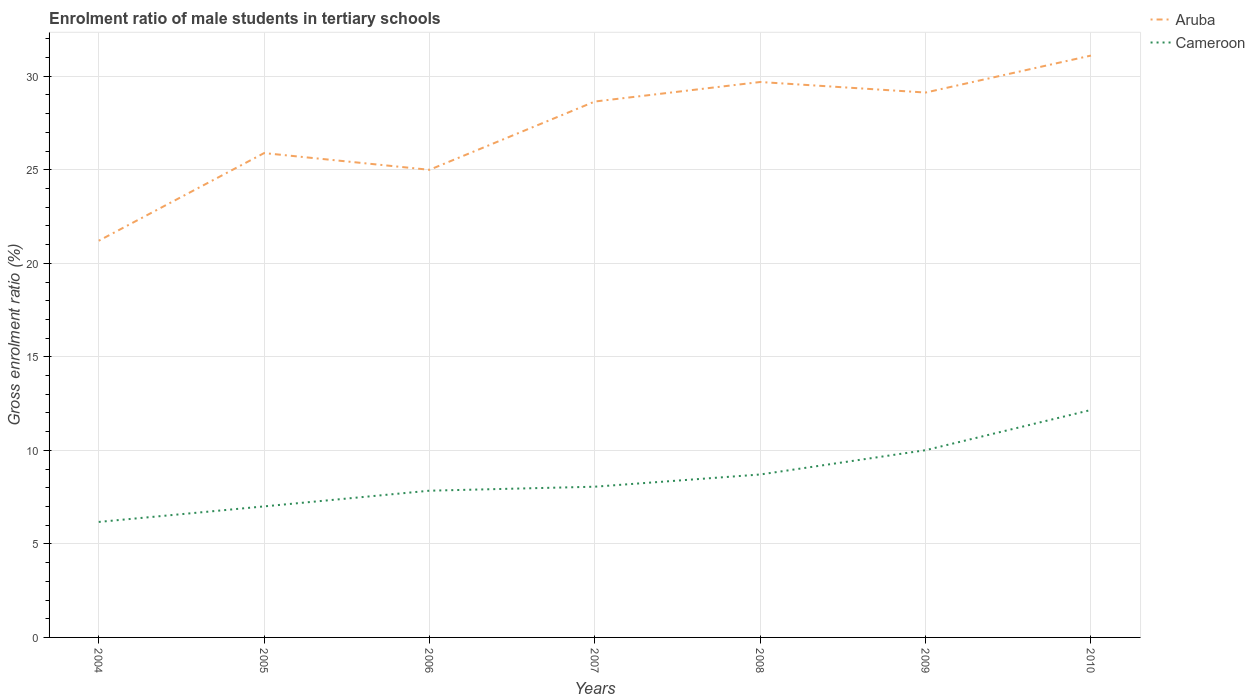Does the line corresponding to Cameroon intersect with the line corresponding to Aruba?
Your response must be concise. No. Is the number of lines equal to the number of legend labels?
Give a very brief answer. Yes. Across all years, what is the maximum enrolment ratio of male students in tertiary schools in Cameroon?
Keep it short and to the point. 6.17. What is the total enrolment ratio of male students in tertiary schools in Aruba in the graph?
Your answer should be compact. -3.24. What is the difference between the highest and the second highest enrolment ratio of male students in tertiary schools in Cameroon?
Your answer should be very brief. 5.99. What is the difference between the highest and the lowest enrolment ratio of male students in tertiary schools in Cameroon?
Keep it short and to the point. 3. Is the enrolment ratio of male students in tertiary schools in Cameroon strictly greater than the enrolment ratio of male students in tertiary schools in Aruba over the years?
Offer a terse response. Yes. How many lines are there?
Give a very brief answer. 2. How many years are there in the graph?
Give a very brief answer. 7. Are the values on the major ticks of Y-axis written in scientific E-notation?
Your answer should be compact. No. Does the graph contain any zero values?
Make the answer very short. No. Does the graph contain grids?
Offer a very short reply. Yes. Where does the legend appear in the graph?
Provide a succinct answer. Top right. What is the title of the graph?
Your answer should be compact. Enrolment ratio of male students in tertiary schools. Does "Saudi Arabia" appear as one of the legend labels in the graph?
Keep it short and to the point. No. What is the label or title of the Y-axis?
Offer a terse response. Gross enrolment ratio (%). What is the Gross enrolment ratio (%) in Aruba in 2004?
Provide a short and direct response. 21.21. What is the Gross enrolment ratio (%) of Cameroon in 2004?
Offer a terse response. 6.17. What is the Gross enrolment ratio (%) in Aruba in 2005?
Your answer should be compact. 25.89. What is the Gross enrolment ratio (%) in Cameroon in 2005?
Provide a short and direct response. 7.01. What is the Gross enrolment ratio (%) in Aruba in 2006?
Your response must be concise. 25. What is the Gross enrolment ratio (%) in Cameroon in 2006?
Offer a terse response. 7.84. What is the Gross enrolment ratio (%) of Aruba in 2007?
Offer a very short reply. 28.65. What is the Gross enrolment ratio (%) in Cameroon in 2007?
Your response must be concise. 8.06. What is the Gross enrolment ratio (%) in Aruba in 2008?
Provide a succinct answer. 29.69. What is the Gross enrolment ratio (%) in Cameroon in 2008?
Provide a succinct answer. 8.71. What is the Gross enrolment ratio (%) in Aruba in 2009?
Make the answer very short. 29.13. What is the Gross enrolment ratio (%) in Cameroon in 2009?
Make the answer very short. 10.01. What is the Gross enrolment ratio (%) of Aruba in 2010?
Offer a terse response. 31.11. What is the Gross enrolment ratio (%) of Cameroon in 2010?
Ensure brevity in your answer.  12.16. Across all years, what is the maximum Gross enrolment ratio (%) of Aruba?
Your answer should be very brief. 31.11. Across all years, what is the maximum Gross enrolment ratio (%) in Cameroon?
Offer a very short reply. 12.16. Across all years, what is the minimum Gross enrolment ratio (%) in Aruba?
Keep it short and to the point. 21.21. Across all years, what is the minimum Gross enrolment ratio (%) of Cameroon?
Offer a very short reply. 6.17. What is the total Gross enrolment ratio (%) in Aruba in the graph?
Provide a short and direct response. 190.68. What is the total Gross enrolment ratio (%) in Cameroon in the graph?
Offer a terse response. 59.96. What is the difference between the Gross enrolment ratio (%) in Aruba in 2004 and that in 2005?
Your response must be concise. -4.69. What is the difference between the Gross enrolment ratio (%) in Cameroon in 2004 and that in 2005?
Your response must be concise. -0.83. What is the difference between the Gross enrolment ratio (%) in Aruba in 2004 and that in 2006?
Your answer should be very brief. -3.79. What is the difference between the Gross enrolment ratio (%) in Cameroon in 2004 and that in 2006?
Your response must be concise. -1.67. What is the difference between the Gross enrolment ratio (%) of Aruba in 2004 and that in 2007?
Provide a short and direct response. -7.44. What is the difference between the Gross enrolment ratio (%) of Cameroon in 2004 and that in 2007?
Your response must be concise. -1.88. What is the difference between the Gross enrolment ratio (%) in Aruba in 2004 and that in 2008?
Give a very brief answer. -8.49. What is the difference between the Gross enrolment ratio (%) in Cameroon in 2004 and that in 2008?
Make the answer very short. -2.54. What is the difference between the Gross enrolment ratio (%) of Aruba in 2004 and that in 2009?
Give a very brief answer. -7.92. What is the difference between the Gross enrolment ratio (%) in Cameroon in 2004 and that in 2009?
Make the answer very short. -3.84. What is the difference between the Gross enrolment ratio (%) of Aruba in 2004 and that in 2010?
Ensure brevity in your answer.  -9.9. What is the difference between the Gross enrolment ratio (%) of Cameroon in 2004 and that in 2010?
Offer a terse response. -5.99. What is the difference between the Gross enrolment ratio (%) in Aruba in 2005 and that in 2006?
Provide a short and direct response. 0.89. What is the difference between the Gross enrolment ratio (%) in Cameroon in 2005 and that in 2006?
Your answer should be very brief. -0.84. What is the difference between the Gross enrolment ratio (%) of Aruba in 2005 and that in 2007?
Give a very brief answer. -2.76. What is the difference between the Gross enrolment ratio (%) in Cameroon in 2005 and that in 2007?
Provide a short and direct response. -1.05. What is the difference between the Gross enrolment ratio (%) of Aruba in 2005 and that in 2008?
Your answer should be very brief. -3.8. What is the difference between the Gross enrolment ratio (%) of Cameroon in 2005 and that in 2008?
Provide a short and direct response. -1.71. What is the difference between the Gross enrolment ratio (%) in Aruba in 2005 and that in 2009?
Ensure brevity in your answer.  -3.24. What is the difference between the Gross enrolment ratio (%) in Cameroon in 2005 and that in 2009?
Your answer should be very brief. -3. What is the difference between the Gross enrolment ratio (%) in Aruba in 2005 and that in 2010?
Keep it short and to the point. -5.21. What is the difference between the Gross enrolment ratio (%) of Cameroon in 2005 and that in 2010?
Your answer should be compact. -5.15. What is the difference between the Gross enrolment ratio (%) of Aruba in 2006 and that in 2007?
Give a very brief answer. -3.65. What is the difference between the Gross enrolment ratio (%) in Cameroon in 2006 and that in 2007?
Keep it short and to the point. -0.21. What is the difference between the Gross enrolment ratio (%) of Aruba in 2006 and that in 2008?
Offer a terse response. -4.69. What is the difference between the Gross enrolment ratio (%) in Cameroon in 2006 and that in 2008?
Provide a succinct answer. -0.87. What is the difference between the Gross enrolment ratio (%) of Aruba in 2006 and that in 2009?
Offer a very short reply. -4.13. What is the difference between the Gross enrolment ratio (%) of Cameroon in 2006 and that in 2009?
Ensure brevity in your answer.  -2.17. What is the difference between the Gross enrolment ratio (%) in Aruba in 2006 and that in 2010?
Offer a very short reply. -6.11. What is the difference between the Gross enrolment ratio (%) of Cameroon in 2006 and that in 2010?
Offer a terse response. -4.32. What is the difference between the Gross enrolment ratio (%) of Aruba in 2007 and that in 2008?
Keep it short and to the point. -1.04. What is the difference between the Gross enrolment ratio (%) of Cameroon in 2007 and that in 2008?
Keep it short and to the point. -0.65. What is the difference between the Gross enrolment ratio (%) in Aruba in 2007 and that in 2009?
Your answer should be very brief. -0.48. What is the difference between the Gross enrolment ratio (%) of Cameroon in 2007 and that in 2009?
Your response must be concise. -1.95. What is the difference between the Gross enrolment ratio (%) in Aruba in 2007 and that in 2010?
Ensure brevity in your answer.  -2.46. What is the difference between the Gross enrolment ratio (%) in Cameroon in 2007 and that in 2010?
Make the answer very short. -4.1. What is the difference between the Gross enrolment ratio (%) of Aruba in 2008 and that in 2009?
Provide a succinct answer. 0.56. What is the difference between the Gross enrolment ratio (%) in Cameroon in 2008 and that in 2009?
Your answer should be compact. -1.3. What is the difference between the Gross enrolment ratio (%) in Aruba in 2008 and that in 2010?
Offer a terse response. -1.41. What is the difference between the Gross enrolment ratio (%) of Cameroon in 2008 and that in 2010?
Ensure brevity in your answer.  -3.45. What is the difference between the Gross enrolment ratio (%) of Aruba in 2009 and that in 2010?
Provide a succinct answer. -1.98. What is the difference between the Gross enrolment ratio (%) in Cameroon in 2009 and that in 2010?
Your answer should be compact. -2.15. What is the difference between the Gross enrolment ratio (%) of Aruba in 2004 and the Gross enrolment ratio (%) of Cameroon in 2005?
Offer a terse response. 14.2. What is the difference between the Gross enrolment ratio (%) of Aruba in 2004 and the Gross enrolment ratio (%) of Cameroon in 2006?
Offer a terse response. 13.36. What is the difference between the Gross enrolment ratio (%) in Aruba in 2004 and the Gross enrolment ratio (%) in Cameroon in 2007?
Ensure brevity in your answer.  13.15. What is the difference between the Gross enrolment ratio (%) of Aruba in 2004 and the Gross enrolment ratio (%) of Cameroon in 2008?
Your answer should be very brief. 12.5. What is the difference between the Gross enrolment ratio (%) of Aruba in 2004 and the Gross enrolment ratio (%) of Cameroon in 2009?
Provide a succinct answer. 11.2. What is the difference between the Gross enrolment ratio (%) in Aruba in 2004 and the Gross enrolment ratio (%) in Cameroon in 2010?
Provide a short and direct response. 9.05. What is the difference between the Gross enrolment ratio (%) in Aruba in 2005 and the Gross enrolment ratio (%) in Cameroon in 2006?
Ensure brevity in your answer.  18.05. What is the difference between the Gross enrolment ratio (%) in Aruba in 2005 and the Gross enrolment ratio (%) in Cameroon in 2007?
Your response must be concise. 17.84. What is the difference between the Gross enrolment ratio (%) in Aruba in 2005 and the Gross enrolment ratio (%) in Cameroon in 2008?
Offer a very short reply. 17.18. What is the difference between the Gross enrolment ratio (%) in Aruba in 2005 and the Gross enrolment ratio (%) in Cameroon in 2009?
Make the answer very short. 15.88. What is the difference between the Gross enrolment ratio (%) of Aruba in 2005 and the Gross enrolment ratio (%) of Cameroon in 2010?
Keep it short and to the point. 13.73. What is the difference between the Gross enrolment ratio (%) in Aruba in 2006 and the Gross enrolment ratio (%) in Cameroon in 2007?
Offer a very short reply. 16.94. What is the difference between the Gross enrolment ratio (%) in Aruba in 2006 and the Gross enrolment ratio (%) in Cameroon in 2008?
Your answer should be very brief. 16.29. What is the difference between the Gross enrolment ratio (%) of Aruba in 2006 and the Gross enrolment ratio (%) of Cameroon in 2009?
Provide a succinct answer. 14.99. What is the difference between the Gross enrolment ratio (%) of Aruba in 2006 and the Gross enrolment ratio (%) of Cameroon in 2010?
Keep it short and to the point. 12.84. What is the difference between the Gross enrolment ratio (%) in Aruba in 2007 and the Gross enrolment ratio (%) in Cameroon in 2008?
Make the answer very short. 19.94. What is the difference between the Gross enrolment ratio (%) of Aruba in 2007 and the Gross enrolment ratio (%) of Cameroon in 2009?
Your answer should be very brief. 18.64. What is the difference between the Gross enrolment ratio (%) of Aruba in 2007 and the Gross enrolment ratio (%) of Cameroon in 2010?
Your answer should be very brief. 16.49. What is the difference between the Gross enrolment ratio (%) in Aruba in 2008 and the Gross enrolment ratio (%) in Cameroon in 2009?
Provide a succinct answer. 19.68. What is the difference between the Gross enrolment ratio (%) in Aruba in 2008 and the Gross enrolment ratio (%) in Cameroon in 2010?
Provide a short and direct response. 17.53. What is the difference between the Gross enrolment ratio (%) in Aruba in 2009 and the Gross enrolment ratio (%) in Cameroon in 2010?
Make the answer very short. 16.97. What is the average Gross enrolment ratio (%) of Aruba per year?
Provide a succinct answer. 27.24. What is the average Gross enrolment ratio (%) of Cameroon per year?
Offer a terse response. 8.57. In the year 2004, what is the difference between the Gross enrolment ratio (%) of Aruba and Gross enrolment ratio (%) of Cameroon?
Your answer should be compact. 15.03. In the year 2005, what is the difference between the Gross enrolment ratio (%) in Aruba and Gross enrolment ratio (%) in Cameroon?
Ensure brevity in your answer.  18.89. In the year 2006, what is the difference between the Gross enrolment ratio (%) of Aruba and Gross enrolment ratio (%) of Cameroon?
Provide a succinct answer. 17.16. In the year 2007, what is the difference between the Gross enrolment ratio (%) of Aruba and Gross enrolment ratio (%) of Cameroon?
Your response must be concise. 20.59. In the year 2008, what is the difference between the Gross enrolment ratio (%) in Aruba and Gross enrolment ratio (%) in Cameroon?
Your answer should be very brief. 20.98. In the year 2009, what is the difference between the Gross enrolment ratio (%) of Aruba and Gross enrolment ratio (%) of Cameroon?
Make the answer very short. 19.12. In the year 2010, what is the difference between the Gross enrolment ratio (%) of Aruba and Gross enrolment ratio (%) of Cameroon?
Your response must be concise. 18.95. What is the ratio of the Gross enrolment ratio (%) of Aruba in 2004 to that in 2005?
Offer a very short reply. 0.82. What is the ratio of the Gross enrolment ratio (%) in Cameroon in 2004 to that in 2005?
Offer a very short reply. 0.88. What is the ratio of the Gross enrolment ratio (%) of Aruba in 2004 to that in 2006?
Provide a succinct answer. 0.85. What is the ratio of the Gross enrolment ratio (%) of Cameroon in 2004 to that in 2006?
Keep it short and to the point. 0.79. What is the ratio of the Gross enrolment ratio (%) of Aruba in 2004 to that in 2007?
Your answer should be very brief. 0.74. What is the ratio of the Gross enrolment ratio (%) of Cameroon in 2004 to that in 2007?
Provide a short and direct response. 0.77. What is the ratio of the Gross enrolment ratio (%) of Aruba in 2004 to that in 2008?
Make the answer very short. 0.71. What is the ratio of the Gross enrolment ratio (%) of Cameroon in 2004 to that in 2008?
Keep it short and to the point. 0.71. What is the ratio of the Gross enrolment ratio (%) of Aruba in 2004 to that in 2009?
Provide a succinct answer. 0.73. What is the ratio of the Gross enrolment ratio (%) of Cameroon in 2004 to that in 2009?
Offer a terse response. 0.62. What is the ratio of the Gross enrolment ratio (%) of Aruba in 2004 to that in 2010?
Offer a terse response. 0.68. What is the ratio of the Gross enrolment ratio (%) of Cameroon in 2004 to that in 2010?
Your response must be concise. 0.51. What is the ratio of the Gross enrolment ratio (%) in Aruba in 2005 to that in 2006?
Offer a terse response. 1.04. What is the ratio of the Gross enrolment ratio (%) in Cameroon in 2005 to that in 2006?
Provide a succinct answer. 0.89. What is the ratio of the Gross enrolment ratio (%) of Aruba in 2005 to that in 2007?
Provide a succinct answer. 0.9. What is the ratio of the Gross enrolment ratio (%) of Cameroon in 2005 to that in 2007?
Your answer should be very brief. 0.87. What is the ratio of the Gross enrolment ratio (%) in Aruba in 2005 to that in 2008?
Keep it short and to the point. 0.87. What is the ratio of the Gross enrolment ratio (%) in Cameroon in 2005 to that in 2008?
Ensure brevity in your answer.  0.8. What is the ratio of the Gross enrolment ratio (%) in Cameroon in 2005 to that in 2009?
Provide a succinct answer. 0.7. What is the ratio of the Gross enrolment ratio (%) in Aruba in 2005 to that in 2010?
Your response must be concise. 0.83. What is the ratio of the Gross enrolment ratio (%) of Cameroon in 2005 to that in 2010?
Offer a very short reply. 0.58. What is the ratio of the Gross enrolment ratio (%) of Aruba in 2006 to that in 2007?
Provide a succinct answer. 0.87. What is the ratio of the Gross enrolment ratio (%) of Cameroon in 2006 to that in 2007?
Make the answer very short. 0.97. What is the ratio of the Gross enrolment ratio (%) of Aruba in 2006 to that in 2008?
Provide a short and direct response. 0.84. What is the ratio of the Gross enrolment ratio (%) in Cameroon in 2006 to that in 2008?
Provide a succinct answer. 0.9. What is the ratio of the Gross enrolment ratio (%) in Aruba in 2006 to that in 2009?
Keep it short and to the point. 0.86. What is the ratio of the Gross enrolment ratio (%) in Cameroon in 2006 to that in 2009?
Make the answer very short. 0.78. What is the ratio of the Gross enrolment ratio (%) of Aruba in 2006 to that in 2010?
Provide a short and direct response. 0.8. What is the ratio of the Gross enrolment ratio (%) of Cameroon in 2006 to that in 2010?
Your response must be concise. 0.65. What is the ratio of the Gross enrolment ratio (%) in Aruba in 2007 to that in 2008?
Your answer should be compact. 0.96. What is the ratio of the Gross enrolment ratio (%) of Cameroon in 2007 to that in 2008?
Your answer should be very brief. 0.93. What is the ratio of the Gross enrolment ratio (%) in Aruba in 2007 to that in 2009?
Make the answer very short. 0.98. What is the ratio of the Gross enrolment ratio (%) in Cameroon in 2007 to that in 2009?
Offer a very short reply. 0.81. What is the ratio of the Gross enrolment ratio (%) of Aruba in 2007 to that in 2010?
Make the answer very short. 0.92. What is the ratio of the Gross enrolment ratio (%) of Cameroon in 2007 to that in 2010?
Ensure brevity in your answer.  0.66. What is the ratio of the Gross enrolment ratio (%) in Aruba in 2008 to that in 2009?
Ensure brevity in your answer.  1.02. What is the ratio of the Gross enrolment ratio (%) in Cameroon in 2008 to that in 2009?
Give a very brief answer. 0.87. What is the ratio of the Gross enrolment ratio (%) in Aruba in 2008 to that in 2010?
Provide a succinct answer. 0.95. What is the ratio of the Gross enrolment ratio (%) in Cameroon in 2008 to that in 2010?
Offer a very short reply. 0.72. What is the ratio of the Gross enrolment ratio (%) in Aruba in 2009 to that in 2010?
Ensure brevity in your answer.  0.94. What is the ratio of the Gross enrolment ratio (%) in Cameroon in 2009 to that in 2010?
Provide a succinct answer. 0.82. What is the difference between the highest and the second highest Gross enrolment ratio (%) in Aruba?
Your answer should be compact. 1.41. What is the difference between the highest and the second highest Gross enrolment ratio (%) of Cameroon?
Make the answer very short. 2.15. What is the difference between the highest and the lowest Gross enrolment ratio (%) in Aruba?
Your answer should be compact. 9.9. What is the difference between the highest and the lowest Gross enrolment ratio (%) in Cameroon?
Your answer should be compact. 5.99. 